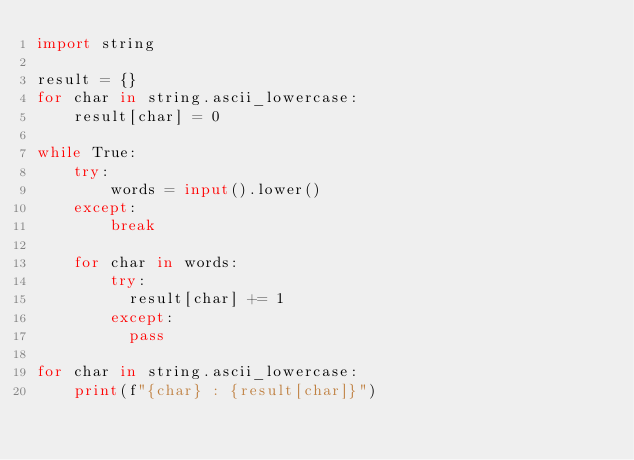Convert code to text. <code><loc_0><loc_0><loc_500><loc_500><_Python_>import string

result = {}
for char in string.ascii_lowercase:
    result[char] = 0

while True:
    try:
        words = input().lower()
    except:
        break
    
    for char in words:
        try:
          result[char] += 1
        except:
          pass

for char in string.ascii_lowercase:
    print(f"{char} : {result[char]}")
</code> 